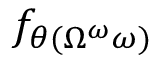Convert formula to latex. <formula><loc_0><loc_0><loc_500><loc_500>f _ { \theta ( \Omega ^ { \omega } \omega ) }</formula> 